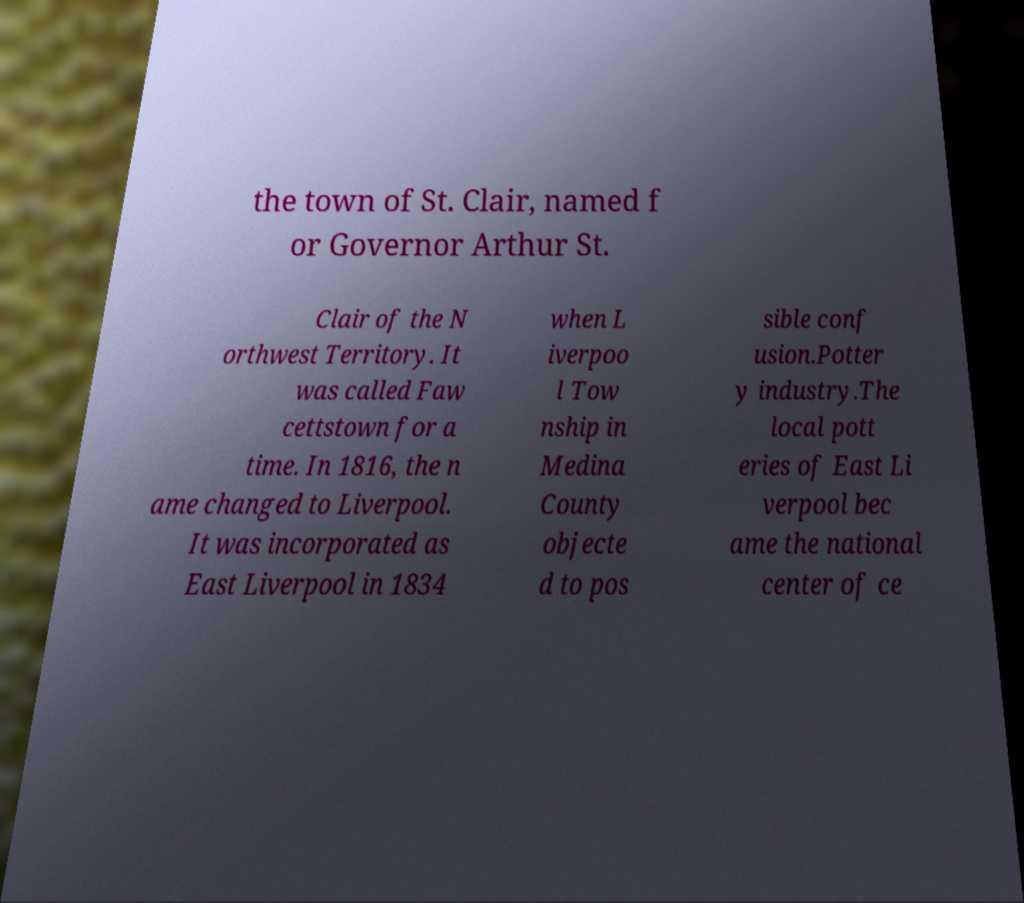There's text embedded in this image that I need extracted. Can you transcribe it verbatim? the town of St. Clair, named f or Governor Arthur St. Clair of the N orthwest Territory. It was called Faw cettstown for a time. In 1816, the n ame changed to Liverpool. It was incorporated as East Liverpool in 1834 when L iverpoo l Tow nship in Medina County objecte d to pos sible conf usion.Potter y industry.The local pott eries of East Li verpool bec ame the national center of ce 